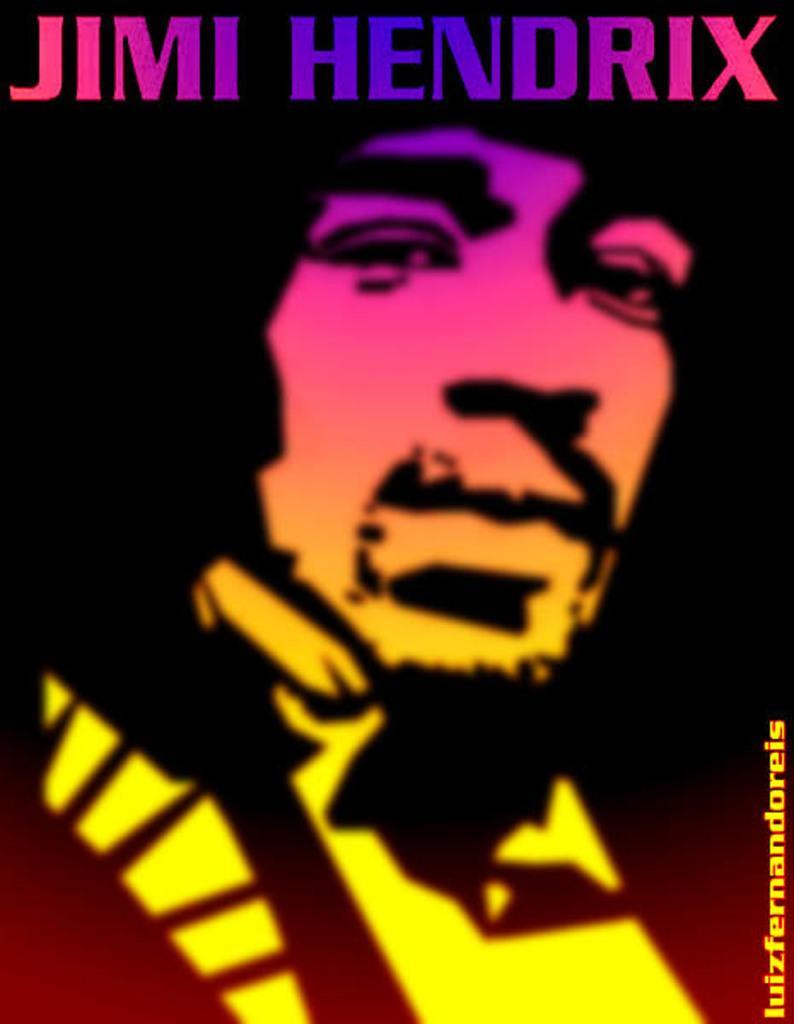Please provide a concise description of this image. In this image, we can see a person in the poster. Top and right side of the image, we can see some text. 